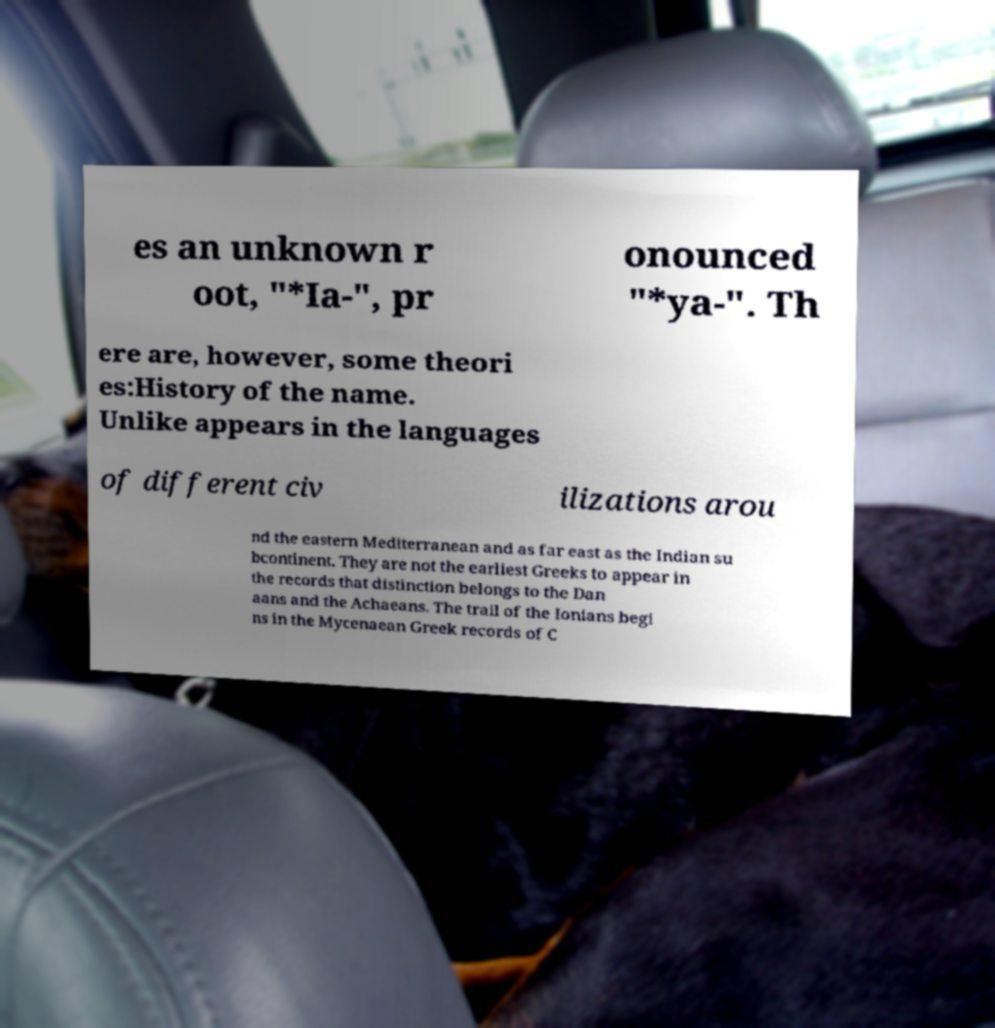There's text embedded in this image that I need extracted. Can you transcribe it verbatim? es an unknown r oot, "*Ia-", pr onounced "*ya-". Th ere are, however, some theori es:History of the name. Unlike appears in the languages of different civ ilizations arou nd the eastern Mediterranean and as far east as the Indian su bcontinent. They are not the earliest Greeks to appear in the records that distinction belongs to the Dan aans and the Achaeans. The trail of the Ionians begi ns in the Mycenaean Greek records of C 